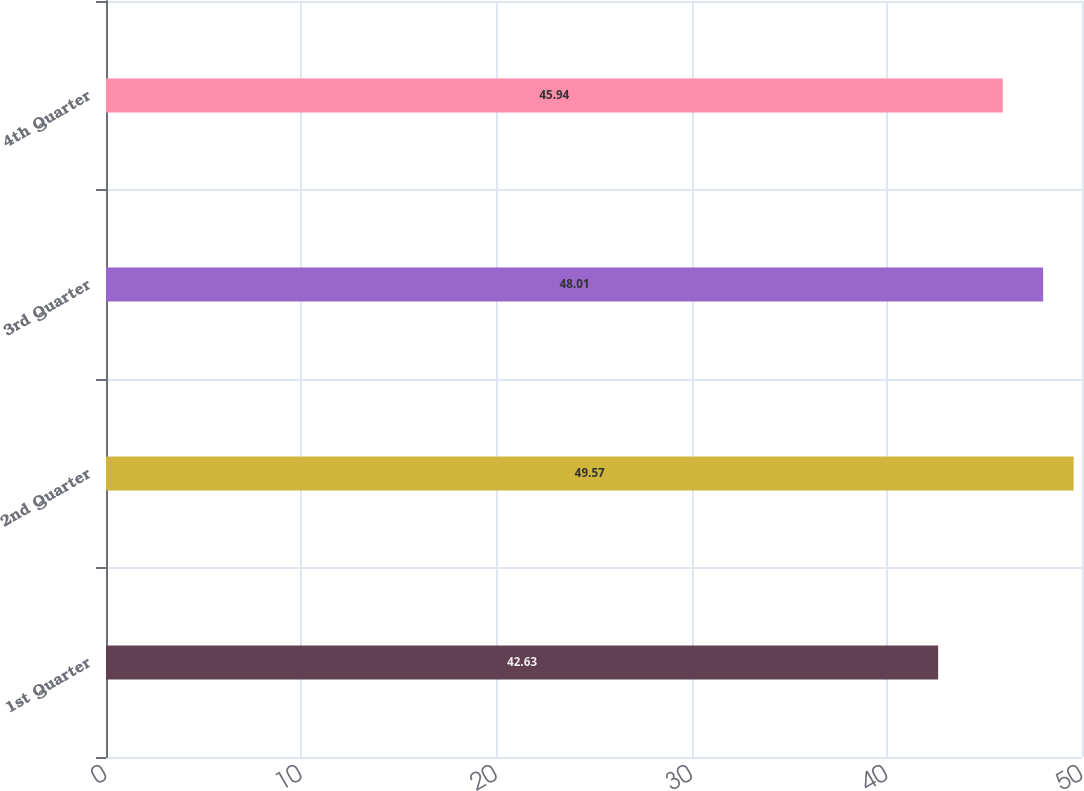<chart> <loc_0><loc_0><loc_500><loc_500><bar_chart><fcel>1st Quarter<fcel>2nd Quarter<fcel>3rd Quarter<fcel>4th Quarter<nl><fcel>42.63<fcel>49.57<fcel>48.01<fcel>45.94<nl></chart> 